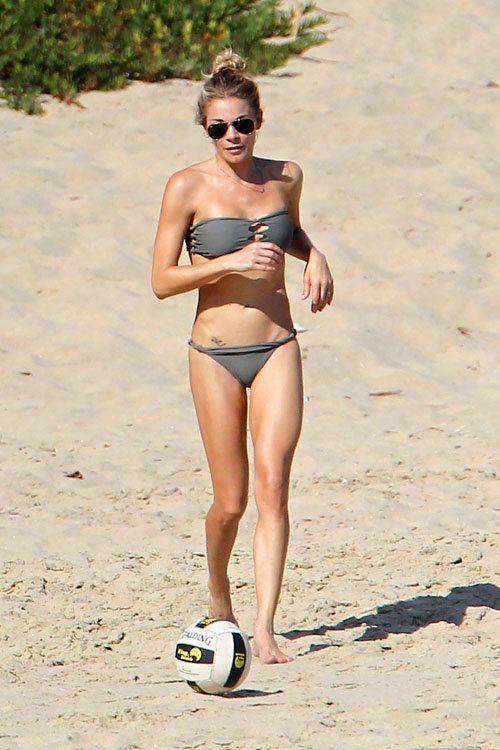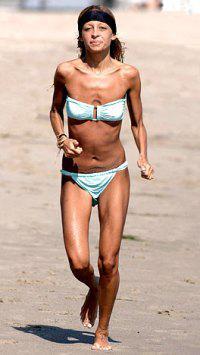The first image is the image on the left, the second image is the image on the right. Analyze the images presented: Is the assertion "The female on the right image has her hair tied up." valid? Answer yes or no. No. The first image is the image on the left, the second image is the image on the right. Examine the images to the left and right. Is the description "One woman is standing in the water." accurate? Answer yes or no. No. 